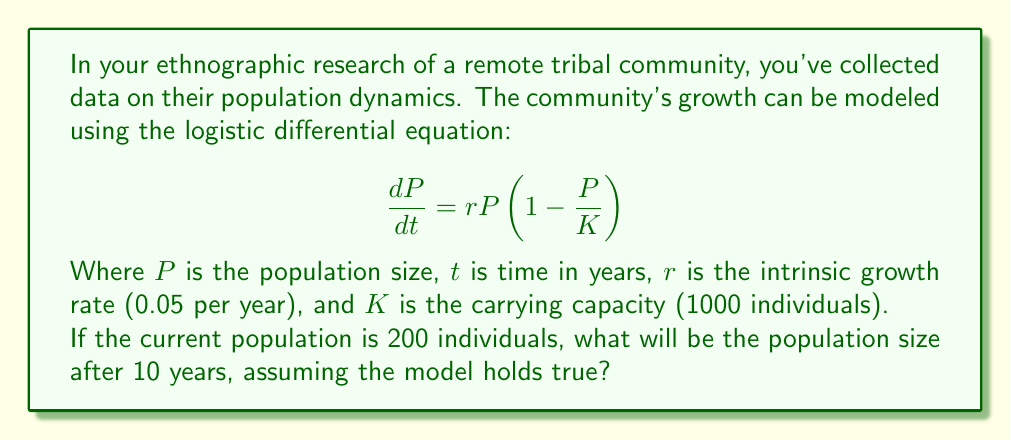Help me with this question. To solve this problem, we need to use the analytical solution of the logistic differential equation:

1) The general solution to the logistic differential equation is:

   $$P(t) = \frac{K}{1 + (\frac{K}{P_0} - 1)e^{-rt}}$$

   Where $P_0$ is the initial population.

2) We're given:
   $K = 1000$ (carrying capacity)
   $r = 0.05$ (intrinsic growth rate)
   $P_0 = 200$ (initial population)
   $t = 10$ (time in years)

3) Let's substitute these values into the equation:

   $$P(10) = \frac{1000}{1 + (\frac{1000}{200} - 1)e^{-0.05 \cdot 10}}$$

4) Simplify:
   $$P(10) = \frac{1000}{1 + 4e^{-0.5}}$$

5) Calculate:
   $e^{-0.5} \approx 0.6065$
   $4e^{-0.5} \approx 2.4260$

6) Substitute back:
   $$P(10) = \frac{1000}{1 + 2.4260} \approx 292.1$$

7) Round to the nearest whole number, as we're dealing with individuals:
   $P(10) \approx 292$ individuals
Answer: 292 individuals 